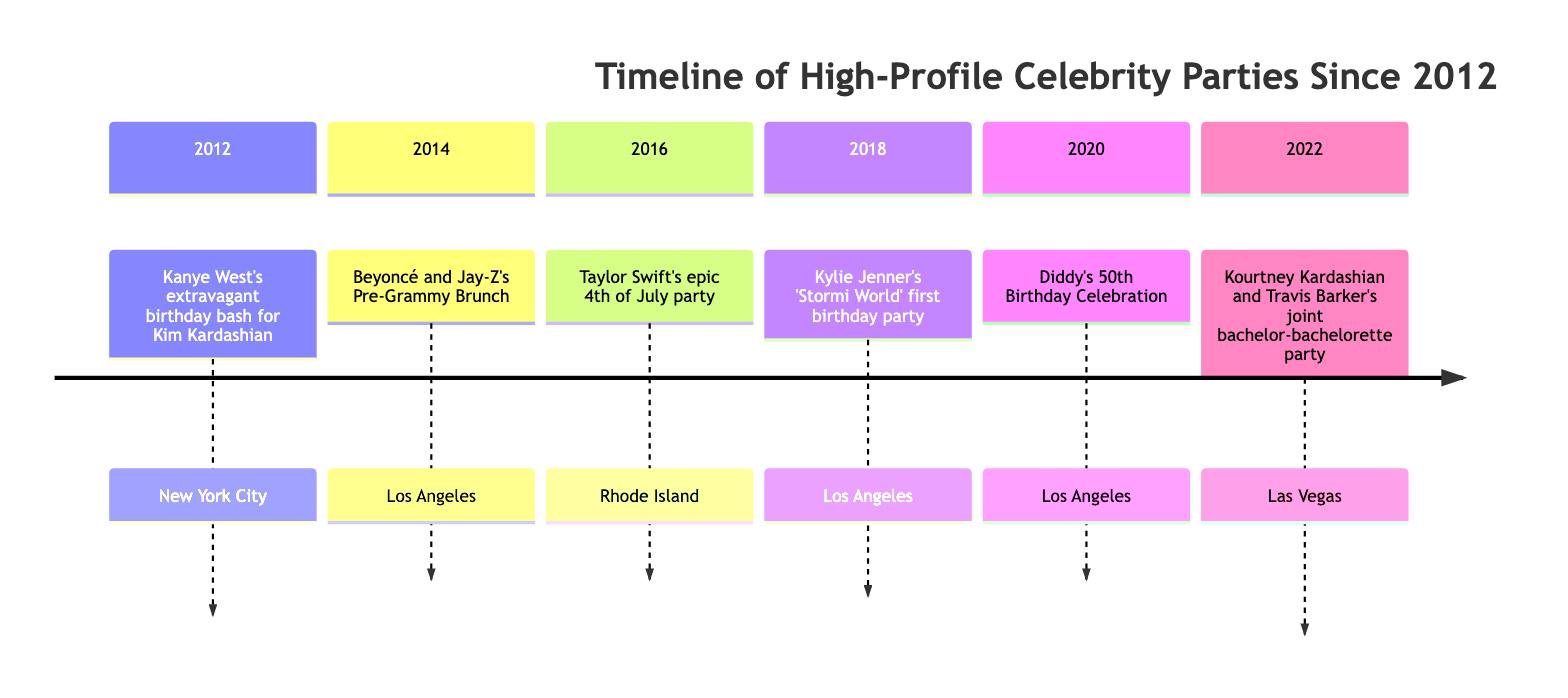What year did Kanye West throw a birthday bash for Kim Kardashian? According to the timeline, Kanye West's extravagant birthday bash for Kim Kardashian occurred in 2012.
Answer: 2012 What event took place in Los Angeles in 2014? The timeline lists Beyoncé and Jay-Z's Pre-Grammy Brunch as the event that took place in Los Angeles in 2014.
Answer: Beyoncé and Jay-Z's Pre-Grammy Brunch How many events are listed in the timeline? The timeline enumerates a total of six events from the years indicated, namely 2012, 2014, 2016, 2018, 2020, and 2022.
Answer: 6 Which celebrity had a birthday party themed after 'Stormi World'? The timeline specifies that Kylie Jenner's first birthday party for Stormi was themed 'Stormi World.'
Answer: Kylie Jenner Which two celebrities were noted as guests at Diddy's 50th Birthday Celebration? To identify the guests, the timeline highlights Leonardo DiCaprio and Kylie Jenner as notable VIP attendees at Diddy's 50th.
Answer: Leonardo DiCaprio and Kylie Jenner What type of entertainment was featured at Taylor Swift's 4th of July party? The timeline mentions that synchronized fireworks display was part of the entertainment at Taylor Swift's party, alongside other activities like a giant inflatable slide.
Answer: Synchronized fireworks display Between which two years did Kylie Jenner's birthday party and Diddy's 50th celebration occur? The timeline indicates that Kylie Jenner's 'Stormi World' birthday party took place in 2018 and Diddy's 50th birthday celebration occurred in 2020, thus spanning from 2018 to 2020.
Answer: 2018 and 2020 What was one highlight of Kourtney Kardashian and Travis Barker's joint bachelor-bachelorette party? The timeline states that one highlight of their event was a private dining experience, among other activities.
Answer: Private dining experience 